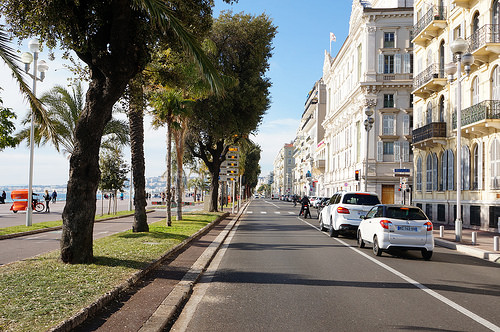<image>
Is there a car in front of the car? Yes. The car is positioned in front of the car, appearing closer to the camera viewpoint. 